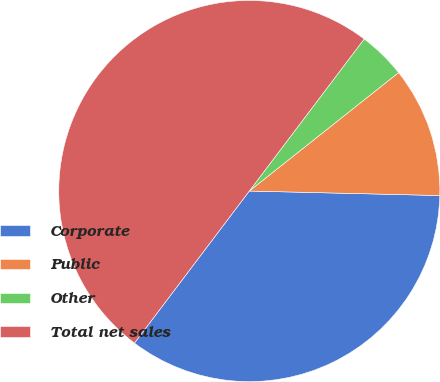<chart> <loc_0><loc_0><loc_500><loc_500><pie_chart><fcel>Corporate<fcel>Public<fcel>Other<fcel>Total net sales<nl><fcel>34.92%<fcel>11.05%<fcel>4.03%<fcel>50.0%<nl></chart> 